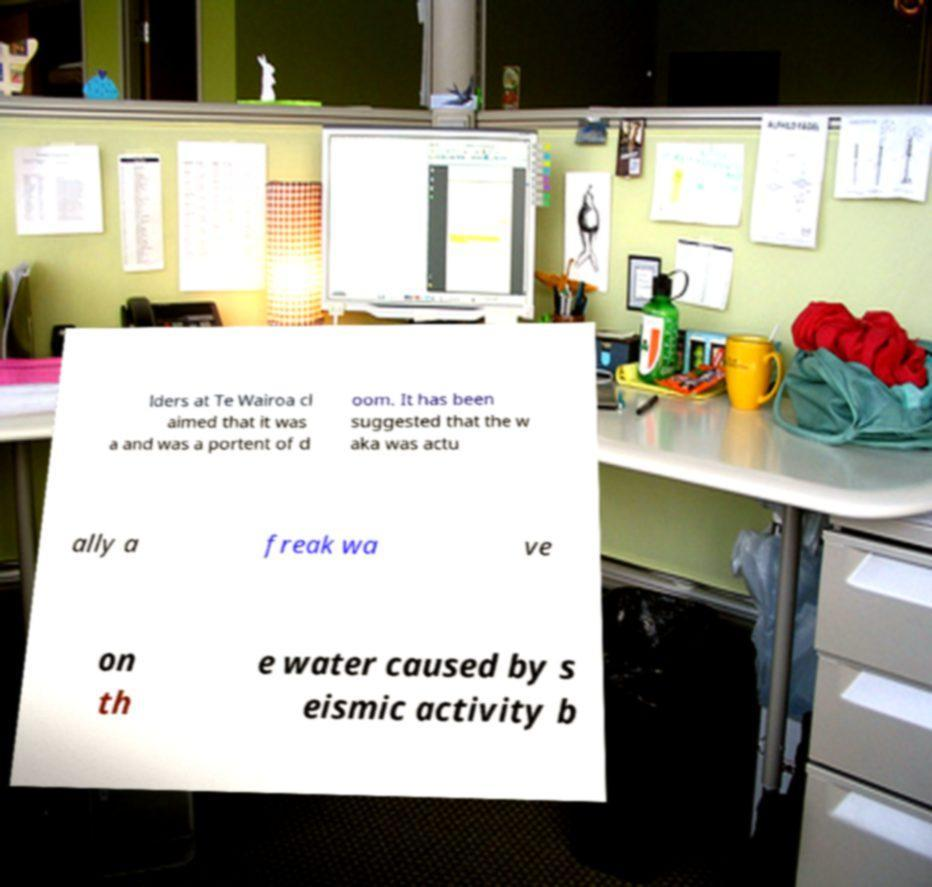Could you assist in decoding the text presented in this image and type it out clearly? lders at Te Wairoa cl aimed that it was a and was a portent of d oom. It has been suggested that the w aka was actu ally a freak wa ve on th e water caused by s eismic activity b 